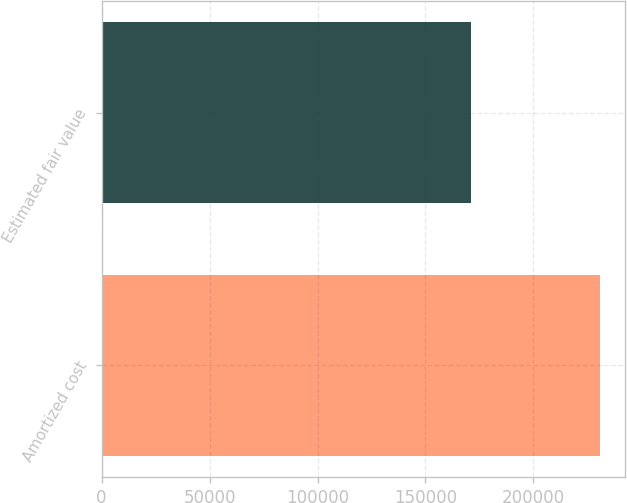Convert chart to OTSL. <chart><loc_0><loc_0><loc_500><loc_500><bar_chart><fcel>Amortized cost<fcel>Estimated fair value<nl><fcel>231040<fcel>171100<nl></chart> 